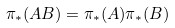Convert formula to latex. <formula><loc_0><loc_0><loc_500><loc_500>\pi _ { * } ( A B ) = \pi _ { * } ( A ) \pi _ { * } ( B )</formula> 